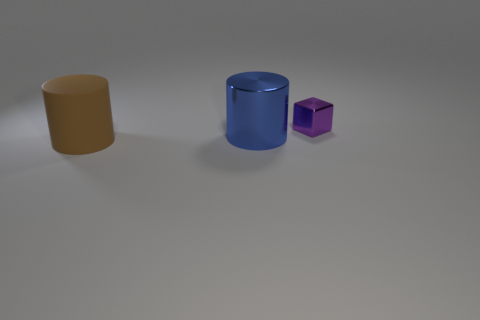Add 2 blocks. How many objects exist? 5 Subtract all blue cylinders. How many cylinders are left? 1 Subtract all cylinders. How many objects are left? 1 Subtract 1 cylinders. How many cylinders are left? 1 Subtract all gray cylinders. Subtract all yellow cubes. How many cylinders are left? 2 Subtract all balls. Subtract all purple blocks. How many objects are left? 2 Add 2 big blue cylinders. How many big blue cylinders are left? 3 Add 2 tiny cyan metal cylinders. How many tiny cyan metal cylinders exist? 2 Subtract 1 purple blocks. How many objects are left? 2 Subtract all brown blocks. How many brown cylinders are left? 1 